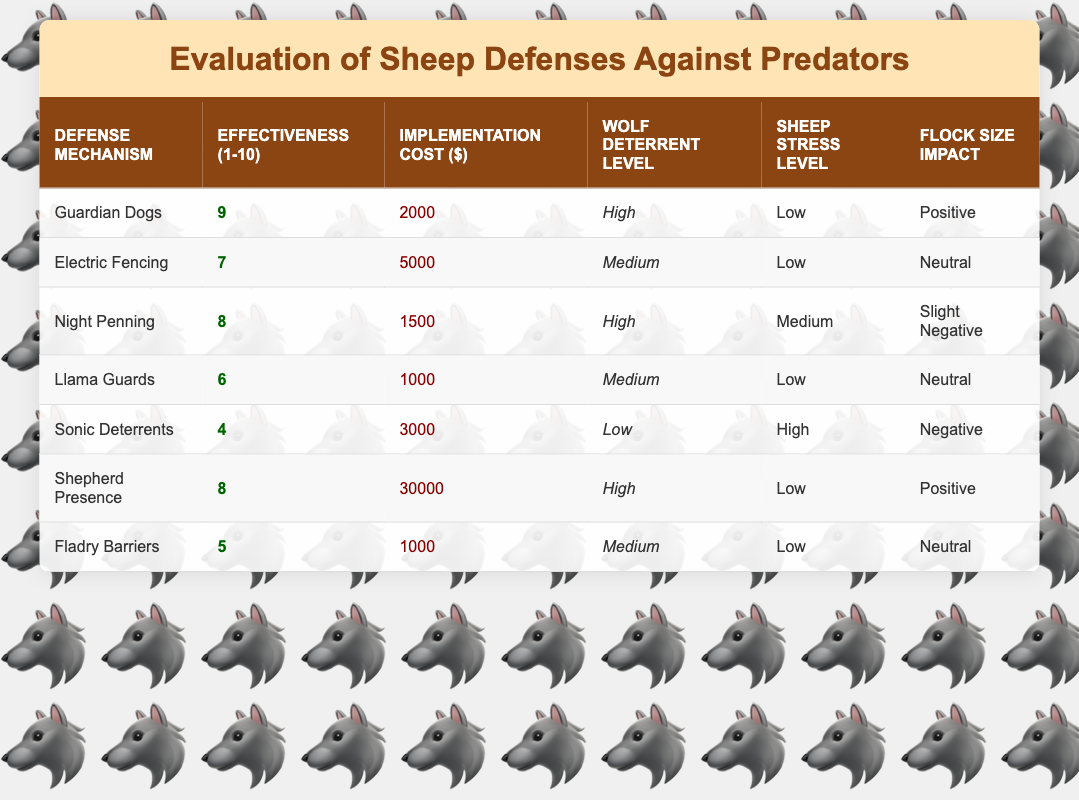What is the effectiveness rating for Guardian Dogs? The effectiveness rating for Guardian Dogs is listed directly in the table under the "Effectiveness (1-10)" column, where it shows a value of 9.
Answer: 9 How much does it cost to implement Sonic Deterrents? The cost of implementing Sonic Deterrents can be found in the "Implementation Cost ($)" column, where it is stated as 3000.
Answer: 3000 Which defense mechanism has the lowest sheep stress level? By examining the "Sheep Stress Level" column, Guardian Dogs, Electric Fencing, Llama Guards, and Fladry Barriers all have a low stress level, but Guardian Dogs are the most effective among them.
Answer: Guardian Dogs, Electric Fencing, Llama Guards, Fladry Barriers What is the average effectiveness rating of the defense mechanisms that provide a high level of wolf deterrent? The defense mechanisms with a high wolf deterrent level are Guardian Dogs, Night Penning, and Shepherd Presence. Their effectiveness ratings are 9, 8, and 8, respectively. We sum these values: (9 + 8 + 8) = 25 and divide by 3, resulting in an average of 25/3 = 8.33.
Answer: 8.33 Is it true that Electric Fencing has a lower effectiveness rating than Llama Guards? Comparing the effectiveness ratings in the table, Electric Fencing has a rating of 7 while Llama Guards have a rating of 6. Since 7 is greater than 6, it is false to say that Electric Fencing has a lower rating.
Answer: No Which defense mechanism has the highest implementation cost, and what is that cost? By reviewing the "Implementation Cost ($)" column, Shepherd Presence has the highest cost listed at 30000.
Answer: Shepherd Presence, 30000 How do the wolf deterrent levels compare between Sonic Deterrents and Fladry Barriers? Sonic Deterrents have a low wolf deterrent level, while Fladry Barriers have a medium level. This shows that Fladry Barriers are more effective at deterring wolves compared to Sonic Deterrents.
Answer: Fladry Barriers are better What is the total cost of the least expensive defense mechanisms? The least expensive mechanisms are Llama Guards and Fladry Barriers, each costing 1000. Adding them gives us (1000 + 1000) = 2000.
Answer: 2000 